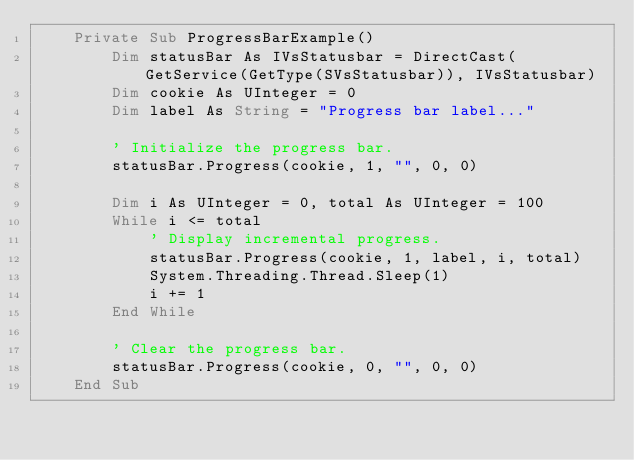Convert code to text. <code><loc_0><loc_0><loc_500><loc_500><_VisualBasic_>    Private Sub ProgressBarExample()
        Dim statusBar As IVsStatusbar = DirectCast(GetService(GetType(SVsStatusbar)), IVsStatusbar)
        Dim cookie As UInteger = 0
        Dim label As String = "Progress bar label..."

        ' Initialize the progress bar. 
        statusBar.Progress(cookie, 1, "", 0, 0)

        Dim i As UInteger = 0, total As UInteger = 100
        While i <= total
            ' Display incremental progress. 
            statusBar.Progress(cookie, 1, label, i, total)
            System.Threading.Thread.Sleep(1)
            i += 1
        End While

        ' Clear the progress bar. 
        statusBar.Progress(cookie, 0, "", 0, 0)
    End Sub</code> 